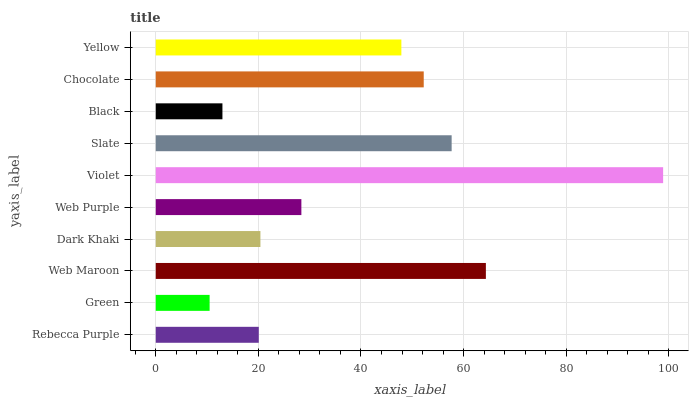Is Green the minimum?
Answer yes or no. Yes. Is Violet the maximum?
Answer yes or no. Yes. Is Web Maroon the minimum?
Answer yes or no. No. Is Web Maroon the maximum?
Answer yes or no. No. Is Web Maroon greater than Green?
Answer yes or no. Yes. Is Green less than Web Maroon?
Answer yes or no. Yes. Is Green greater than Web Maroon?
Answer yes or no. No. Is Web Maroon less than Green?
Answer yes or no. No. Is Yellow the high median?
Answer yes or no. Yes. Is Web Purple the low median?
Answer yes or no. Yes. Is Slate the high median?
Answer yes or no. No. Is Web Maroon the low median?
Answer yes or no. No. 